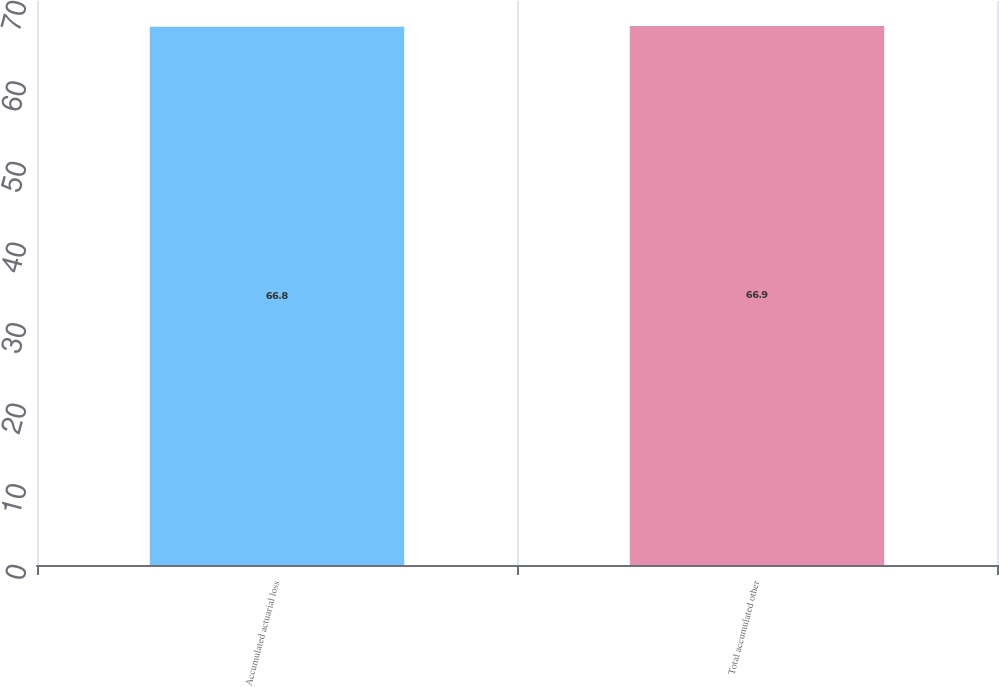Convert chart. <chart><loc_0><loc_0><loc_500><loc_500><bar_chart><fcel>Accumulated actuarial loss<fcel>Total accumulated other<nl><fcel>66.8<fcel>66.9<nl></chart> 